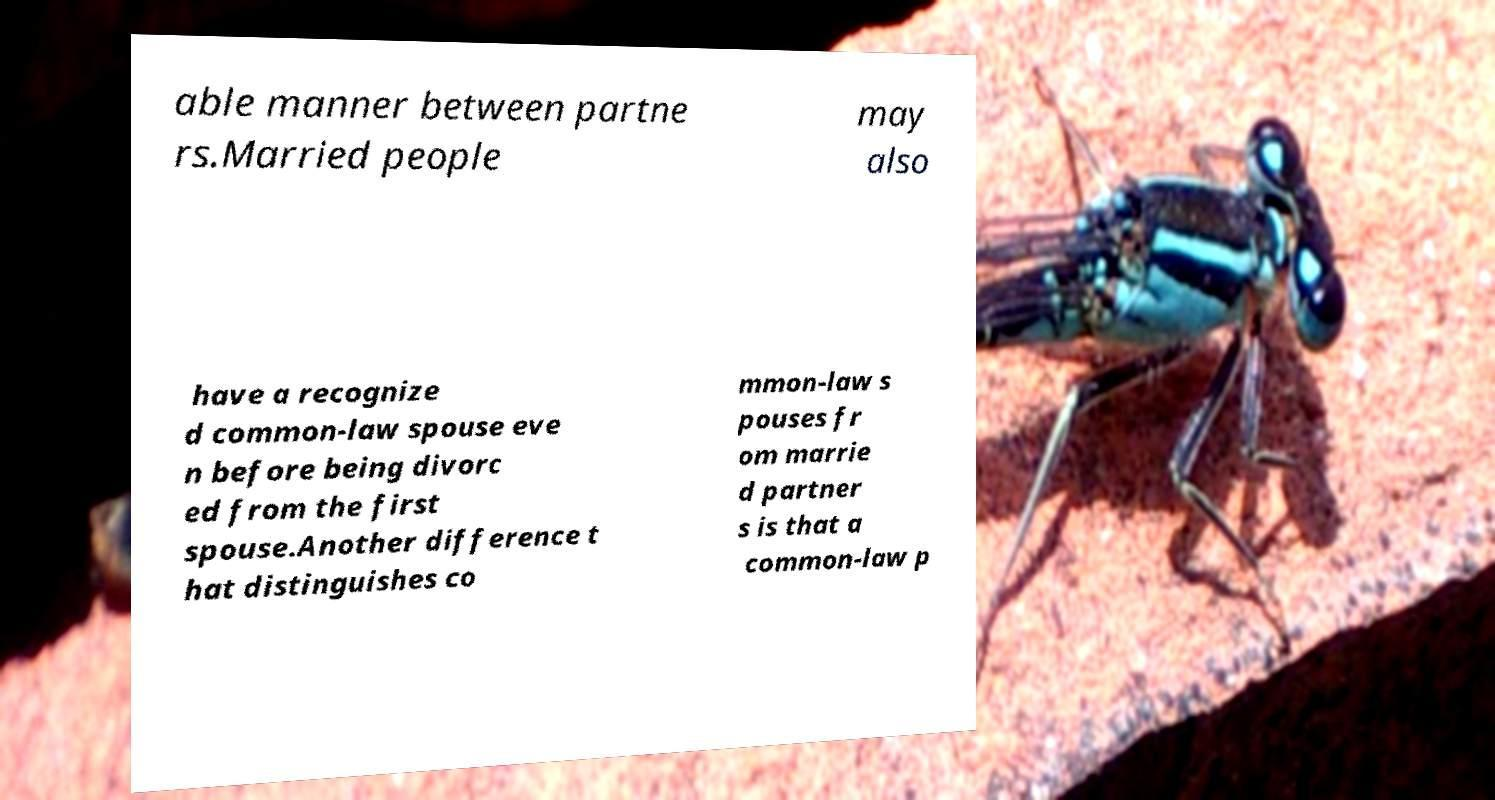What messages or text are displayed in this image? I need them in a readable, typed format. able manner between partne rs.Married people may also have a recognize d common-law spouse eve n before being divorc ed from the first spouse.Another difference t hat distinguishes co mmon-law s pouses fr om marrie d partner s is that a common-law p 